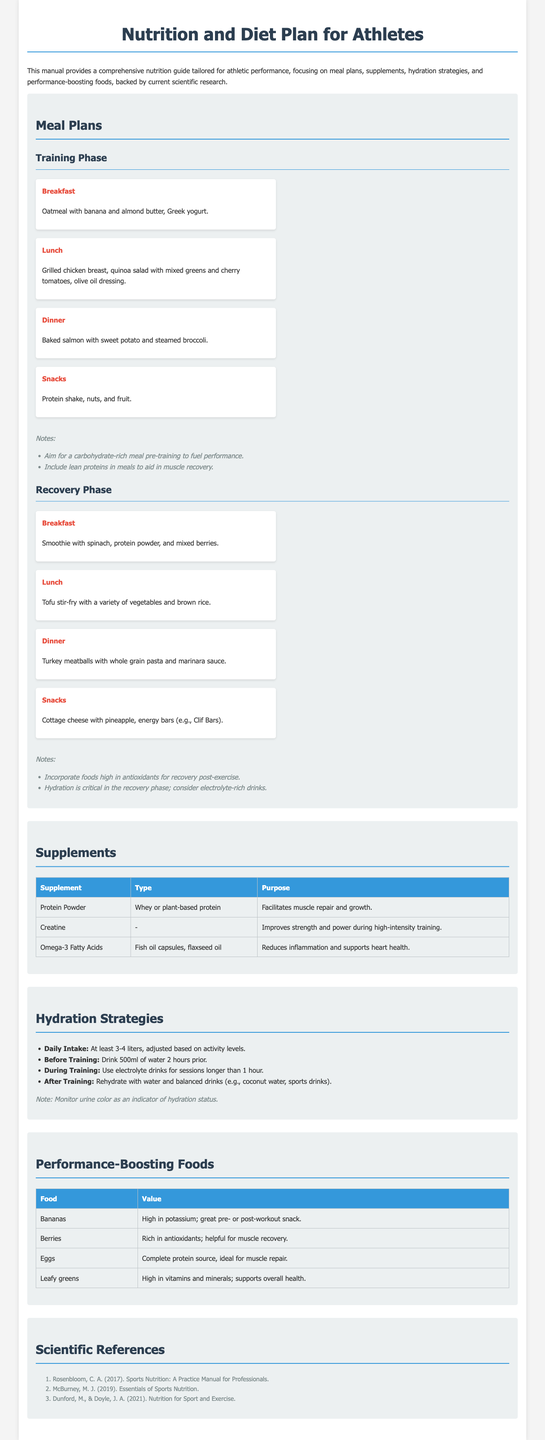What is the primary focus of the manual? The manual provides a comprehensive nutrition guide tailored for athletic performance, focusing on meal plans, supplements, hydration strategies, and performance-boosting foods.
Answer: Athletic performance How many liters of water should athletes drink daily? The document states that athletes should drink at least 3-4 liters, adjusted based on activity levels.
Answer: 3-4 liters What type of meal is suggested for breakfast during the recovery phase? The meal plan specifies a smoothie with spinach, protein powder, and mixed berries for breakfast during the recovery phase.
Answer: Smoothie with spinach, protein powder, and mixed berries What is the main purpose of omega-3 fatty acids as a supplement? The purpose of omega-3 fatty acids is to reduce inflammation and support heart health, as mentioned in the supplements section.
Answer: Reduces inflammation and supports heart health What is recommended to eat as a post-workout snack? Cottage cheese with pineapple and energy bars (e.g., Clif Bars) is listed as snacks for the recovery phase.
Answer: Cottage cheese with pineapple, energy bars How many references are provided in the document? There are three scientific references provided in the references section of the document.
Answer: 3 What meal is suggested for lunch during the training phase? The manual suggests grilled chicken breast, quinoa salad with mixed greens and cherry tomatoes, olive oil dressing for lunch during the training phase.
Answer: Grilled chicken breast, quinoa salad What color is mentioned as an indicator of hydration status? The document mentions urine color as an indicator of hydration status.
Answer: Urine color 